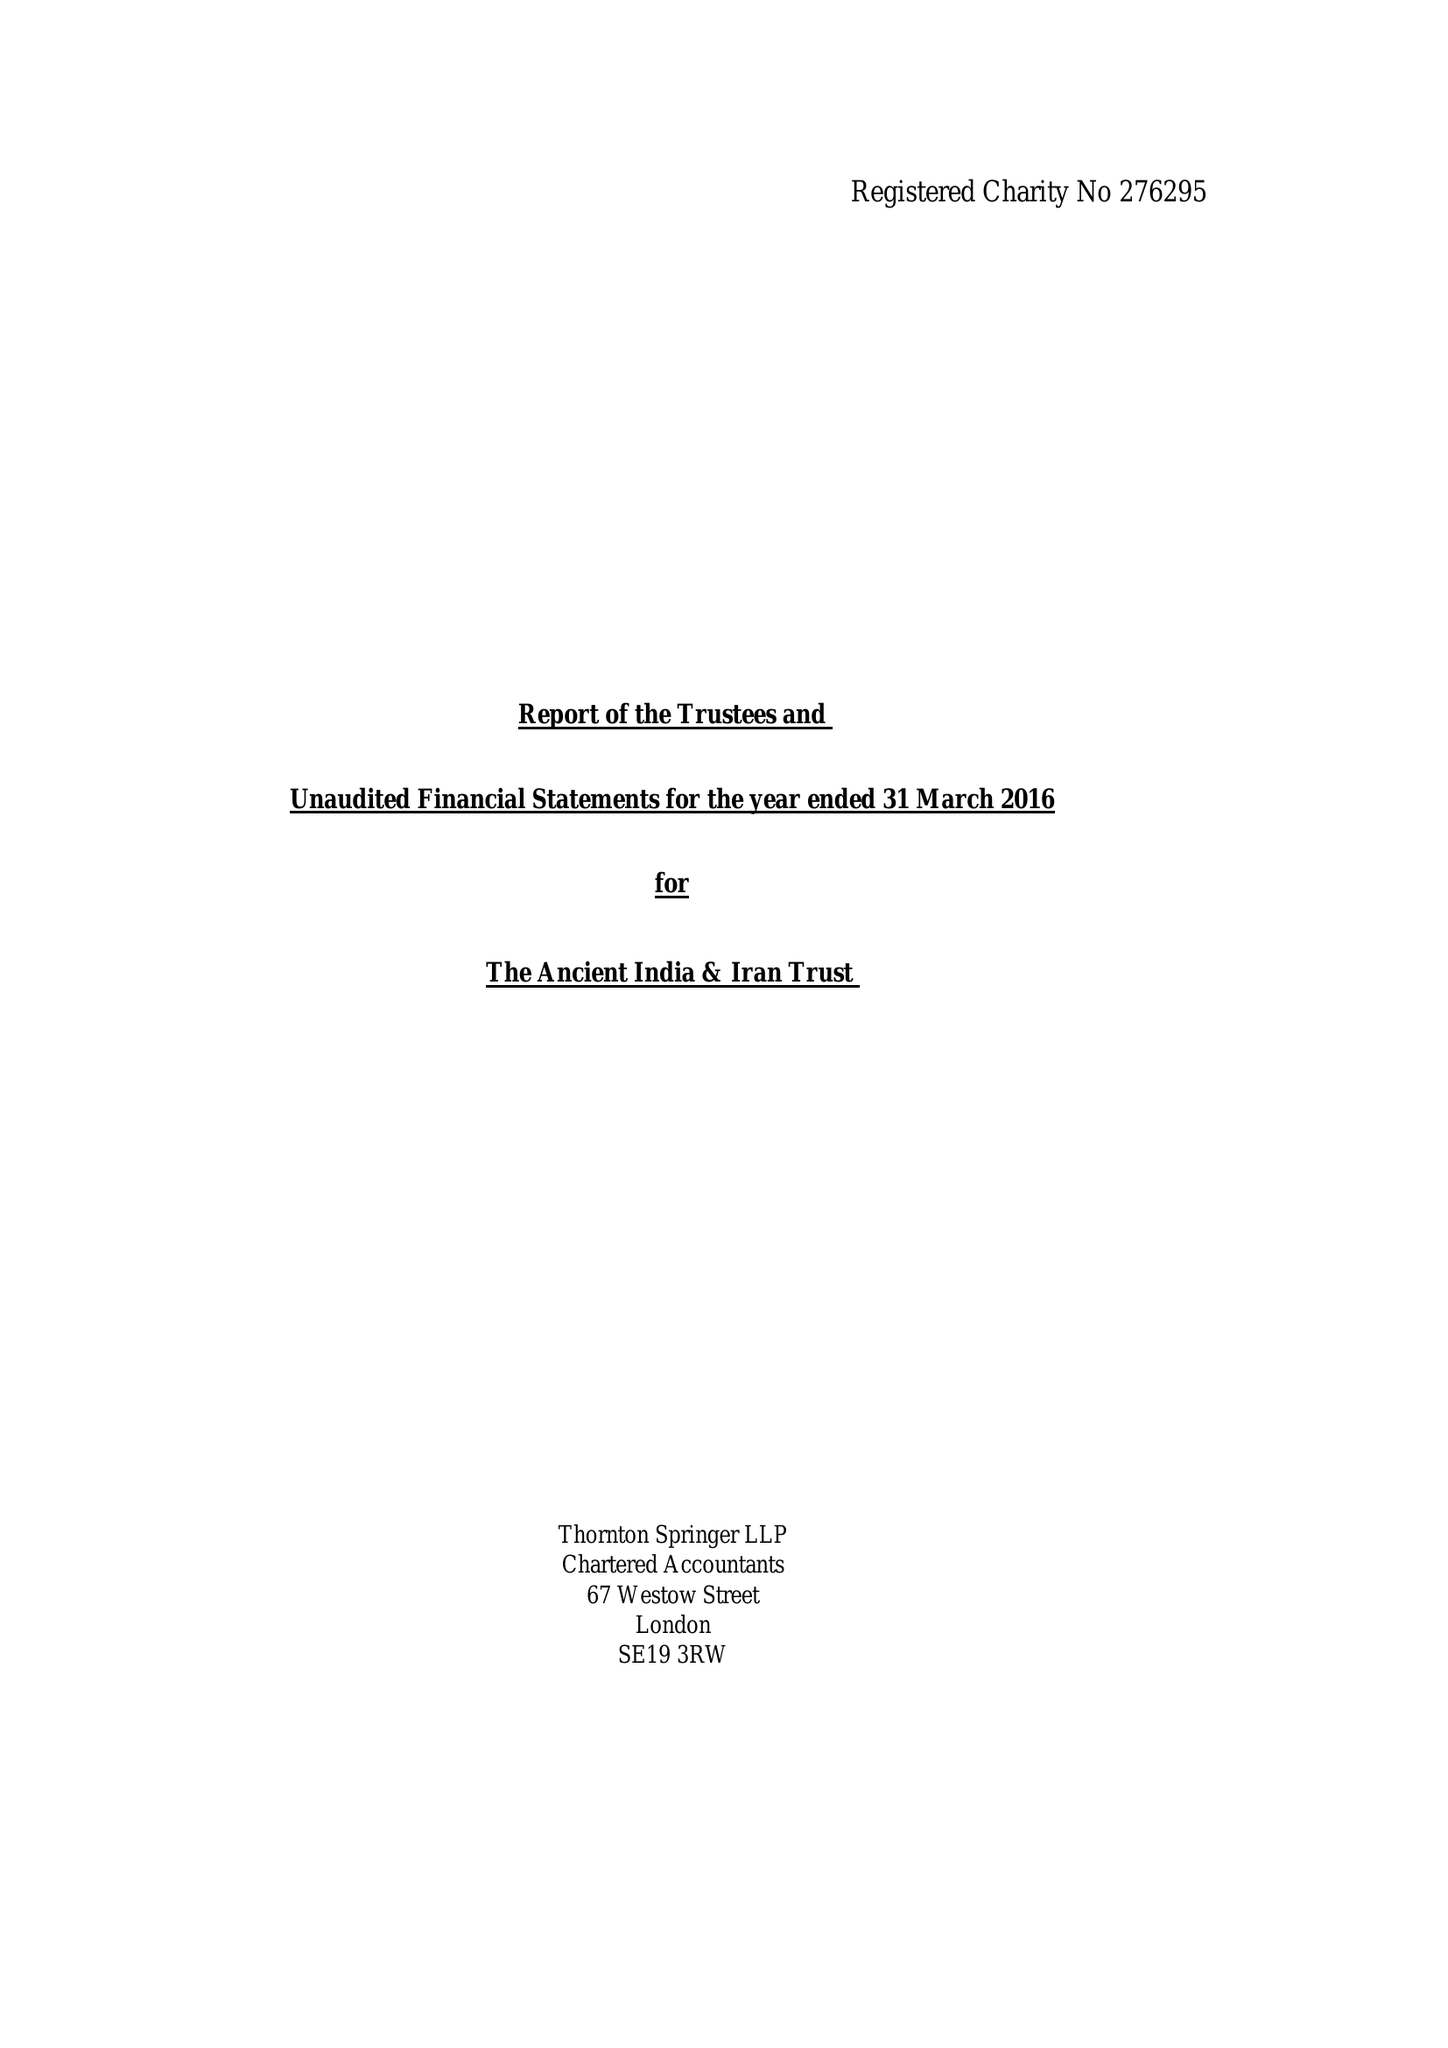What is the value for the address__post_town?
Answer the question using a single word or phrase. CAMBRIDGE 